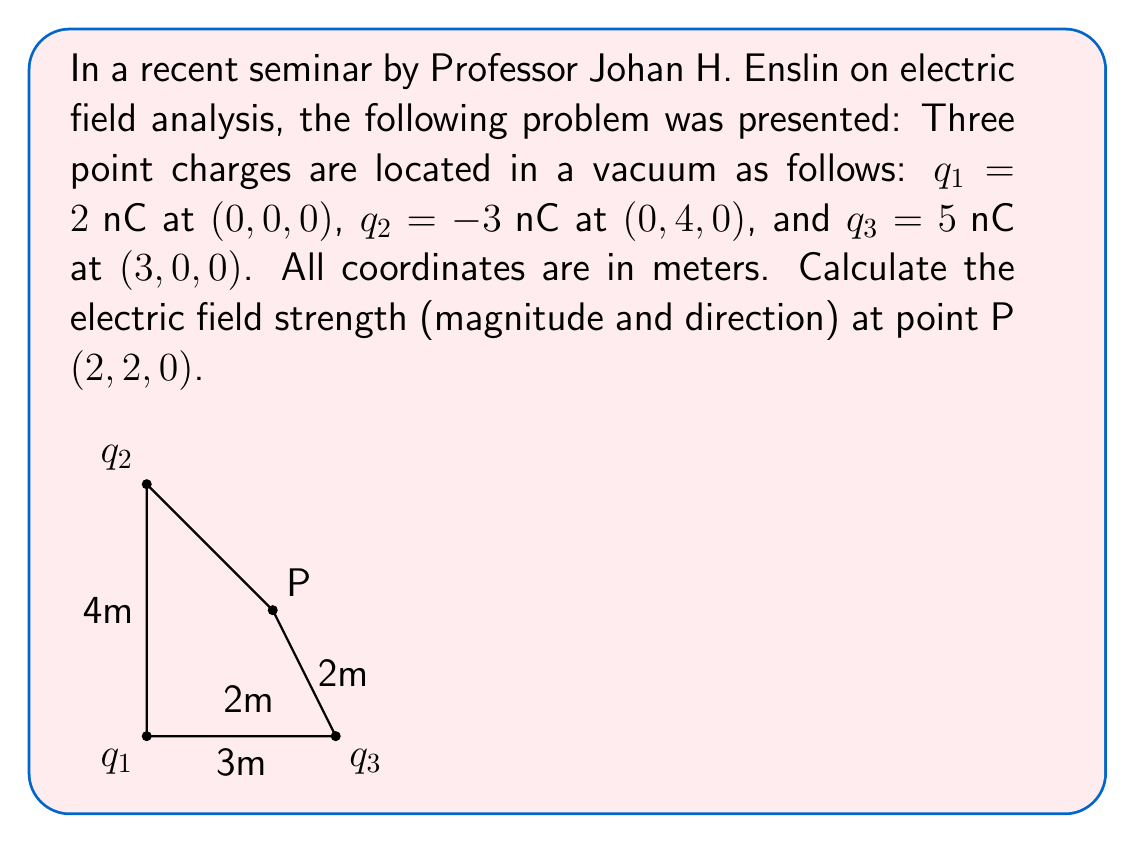Solve this math problem. Let's approach this step-by-step:

1) The electric field due to a point charge is given by:

   $$\vec{E} = \frac{1}{4\pi\epsilon_0} \frac{q}{r^2} \hat{r}$$

   where $\epsilon_0 = 8.85 \times 10^{-12} \text{ F/m}$, $q$ is the charge, $r$ is the distance from the charge to the point of interest, and $\hat{r}$ is the unit vector pointing from the charge to the point.

2) We need to calculate the electric field due to each charge and then sum them vectorially.

3) For $q_1$:
   - $r_1 = \sqrt{2^2 + 2^2} = 2\sqrt{2} \text{ m}$
   - $\hat{r}_1 = \frac{1}{2\sqrt{2}}(2\hat{i} + 2\hat{j})$
   - $\vec{E}_1 = \frac{1}{4\pi\epsilon_0} \frac{2 \times 10^{-9}}{(2\sqrt{2})^2} \frac{1}{2\sqrt{2}}(2\hat{i} + 2\hat{j})$
   
4) For $q_2$:
   - $r_2 = \sqrt{2^2 + 2^2} = 2\sqrt{2} \text{ m}$
   - $\hat{r}_2 = \frac{1}{2\sqrt{2}}(2\hat{i} - 2\hat{j})$
   - $\vec{E}_2 = \frac{1}{4\pi\epsilon_0} \frac{-3 \times 10^{-9}}{(2\sqrt{2})^2} \frac{1}{2\sqrt{2}}(2\hat{i} - 2\hat{j})$

5) For $q_3$:
   - $r_3 = \sqrt{1^2 + 2^2} = \sqrt{5} \text{ m}$
   - $\hat{r}_3 = \frac{1}{\sqrt{5}}(-\hat{i} + 2\hat{j})$
   - $\vec{E}_3 = \frac{1}{4\pi\epsilon_0} \frac{5 \times 10^{-9}}{5} \frac{1}{\sqrt{5}}(-\hat{i} + 2\hat{j})$

6) The total electric field is the sum of these three fields:

   $$\vec{E} = \vec{E}_1 + \vec{E}_2 + \vec{E}_3$$

7) Substituting the values and simplifying:

   $$\vec{E} = \frac{1}{4\pi\epsilon_0} [(0.125\hat{i} + 0.125\hat{j}) + (-0.1875\hat{i} + 0.1875\hat{j}) + (-0.4472\hat{i} + 0.8944\hat{j})] \text{ N/C}$$

8) Combining like terms:

   $$\vec{E} = \frac{1}{4\pi\epsilon_0} (-0.5097\hat{i} + 1.2069\hat{j}) \text{ N/C}$$

9) The magnitude of this field is:

   $$|\vec{E}| = \frac{1}{4\pi\epsilon_0} \sqrt{(-0.5097)^2 + (1.2069)^2} = \frac{1.3095}{4\pi\epsilon_0} \text{ N/C}$$

10) The direction is given by the angle:

    $$\theta = \tan^{-1}\left(\frac{1.2069}{-0.5097}\right) = -67.1°$$

    This angle is with respect to the negative x-axis.
Answer: $\vec{E} = 3.70 \times 10^4 \text{ N/C}$ at $-67.1°$ from the negative x-axis 